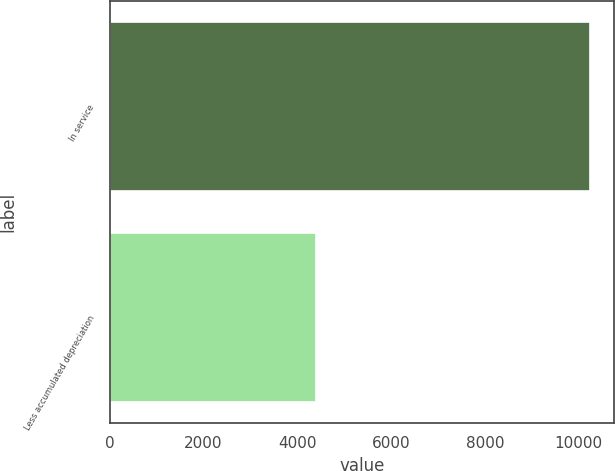Convert chart. <chart><loc_0><loc_0><loc_500><loc_500><bar_chart><fcel>In service<fcel>Less accumulated depreciation<nl><fcel>10236<fcel>4403<nl></chart> 